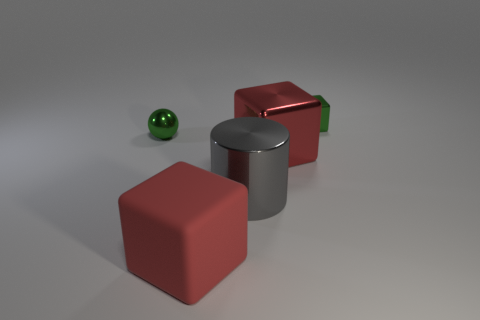Is the small shiny block the same color as the metallic ball?
Provide a short and direct response. Yes. Does the red cube to the right of the gray object have the same material as the small green cube?
Keep it short and to the point. Yes. Is the shape of the large gray shiny object the same as the big red matte thing?
Your answer should be compact. No. What number of red rubber things are behind the small green thing that is on the left side of the tiny green metal cube?
Keep it short and to the point. 0. What material is the other large red thing that is the same shape as the red metallic object?
Keep it short and to the point. Rubber. Does the large metal object in front of the large red shiny object have the same color as the rubber cube?
Give a very brief answer. No. Is the material of the small green sphere the same as the red thing behind the large rubber cube?
Provide a short and direct response. Yes. What shape is the green shiny thing that is behind the tiny green sphere?
Your answer should be compact. Cube. What number of other objects are the same material as the gray object?
Provide a succinct answer. 3. What size is the metal sphere?
Your answer should be very brief. Small. 